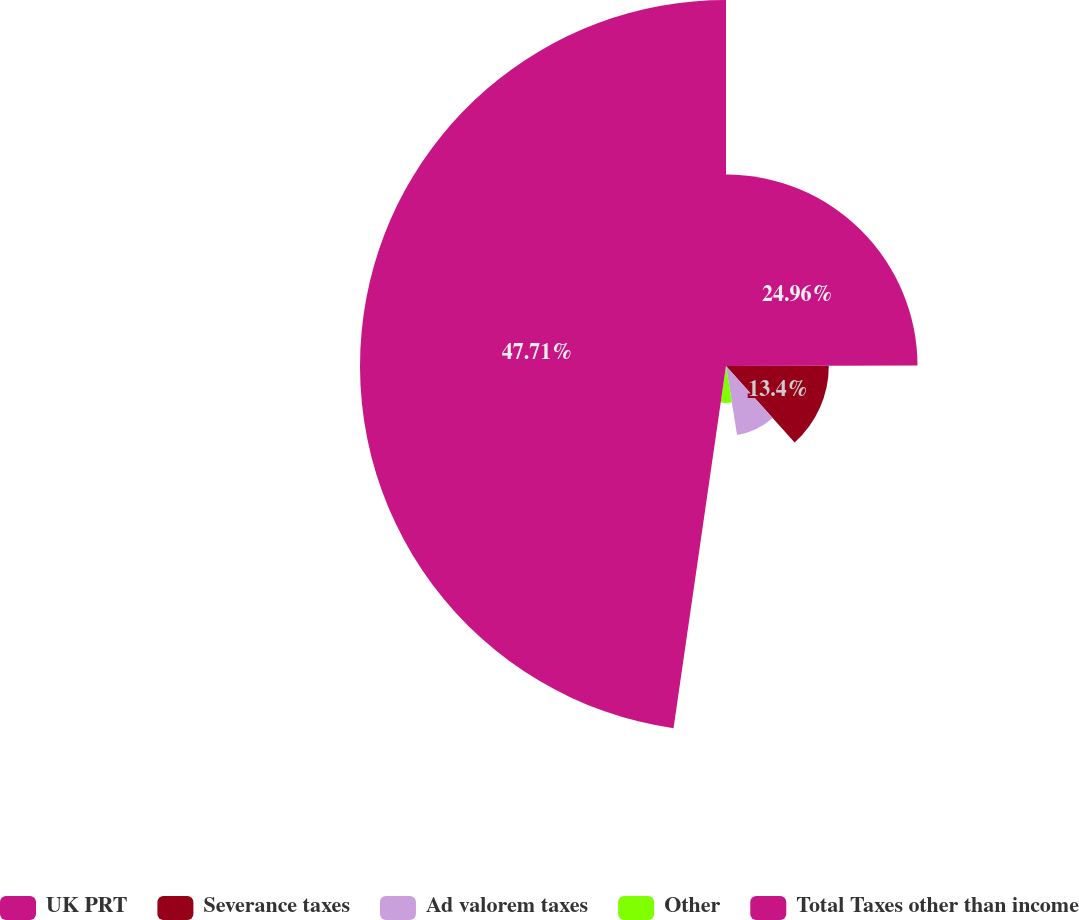Convert chart. <chart><loc_0><loc_0><loc_500><loc_500><pie_chart><fcel>UK PRT<fcel>Severance taxes<fcel>Ad valorem taxes<fcel>Other<fcel>Total Taxes other than income<nl><fcel>24.97%<fcel>13.4%<fcel>9.11%<fcel>4.82%<fcel>47.72%<nl></chart> 